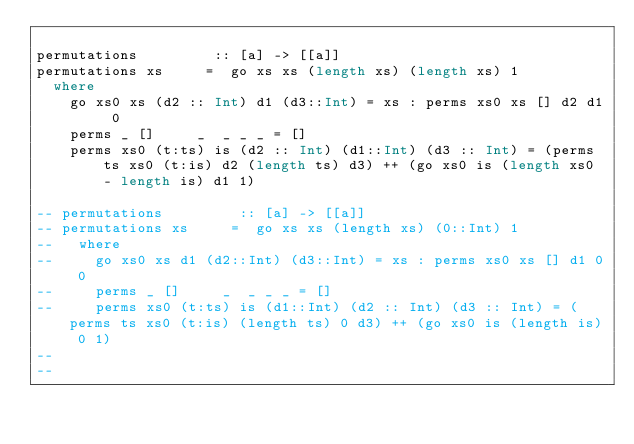<code> <loc_0><loc_0><loc_500><loc_500><_Haskell_>
permutations         :: [a] -> [[a]]
permutations xs     =  go xs xs (length xs) (length xs) 1
  where
    go xs0 xs (d2 :: Int) d1 (d3::Int) = xs : perms xs0 xs [] d2 d1 0
    perms _ []     _  _ _ _ = []
    perms xs0 (t:ts) is (d2 :: Int) (d1::Int) (d3 :: Int) = (perms ts xs0 (t:is) d2 (length ts) d3) ++ (go xs0 is (length xs0 - length is) d1 1)

-- permutations         :: [a] -> [[a]]
-- permutations xs     =  go xs xs (length xs) (0::Int) 1
--   where
--     go xs0 xs d1 (d2::Int) (d3::Int) = xs : perms xs0 xs [] d1 0 0
--     perms _ []     _  _ _ _ = []
--     perms xs0 (t:ts) is (d1::Int) (d2 :: Int) (d3 :: Int) = (perms ts xs0 (t:is) (length ts) 0 d3) ++ (go xs0 is (length is) 0 1)
-- 
-- 
</code> 